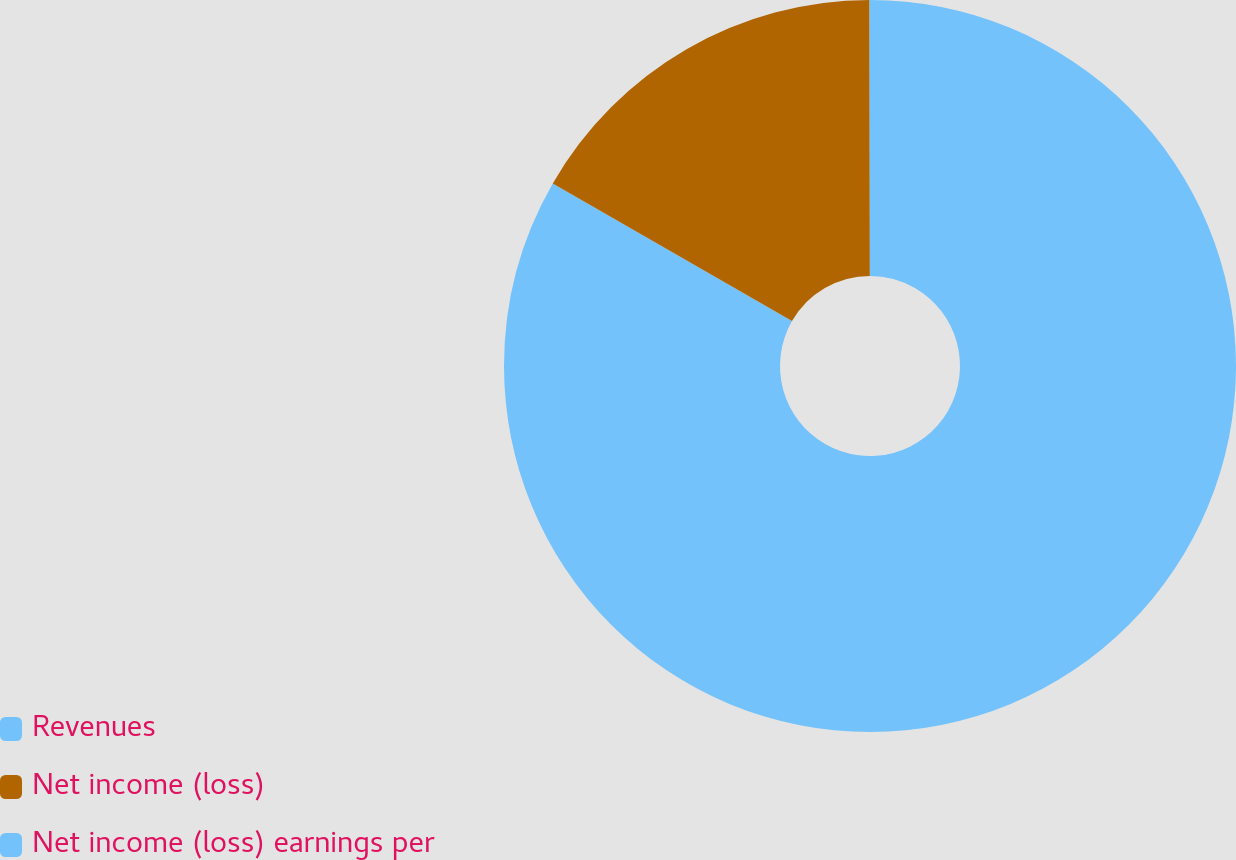Convert chart. <chart><loc_0><loc_0><loc_500><loc_500><pie_chart><fcel>Revenues<fcel>Net income (loss)<fcel>Net income (loss) earnings per<nl><fcel>83.31%<fcel>16.67%<fcel>0.02%<nl></chart> 